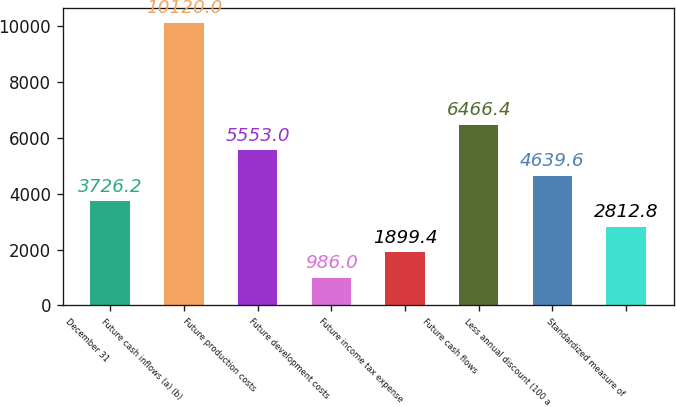<chart> <loc_0><loc_0><loc_500><loc_500><bar_chart><fcel>December 31<fcel>Future cash inflows (a) (b)<fcel>Future production costs<fcel>Future development costs<fcel>Future income tax expense<fcel>Future cash flows<fcel>Less annual discount (100 a<fcel>Standardized measure of<nl><fcel>3726.2<fcel>10120<fcel>5553<fcel>986<fcel>1899.4<fcel>6466.4<fcel>4639.6<fcel>2812.8<nl></chart> 